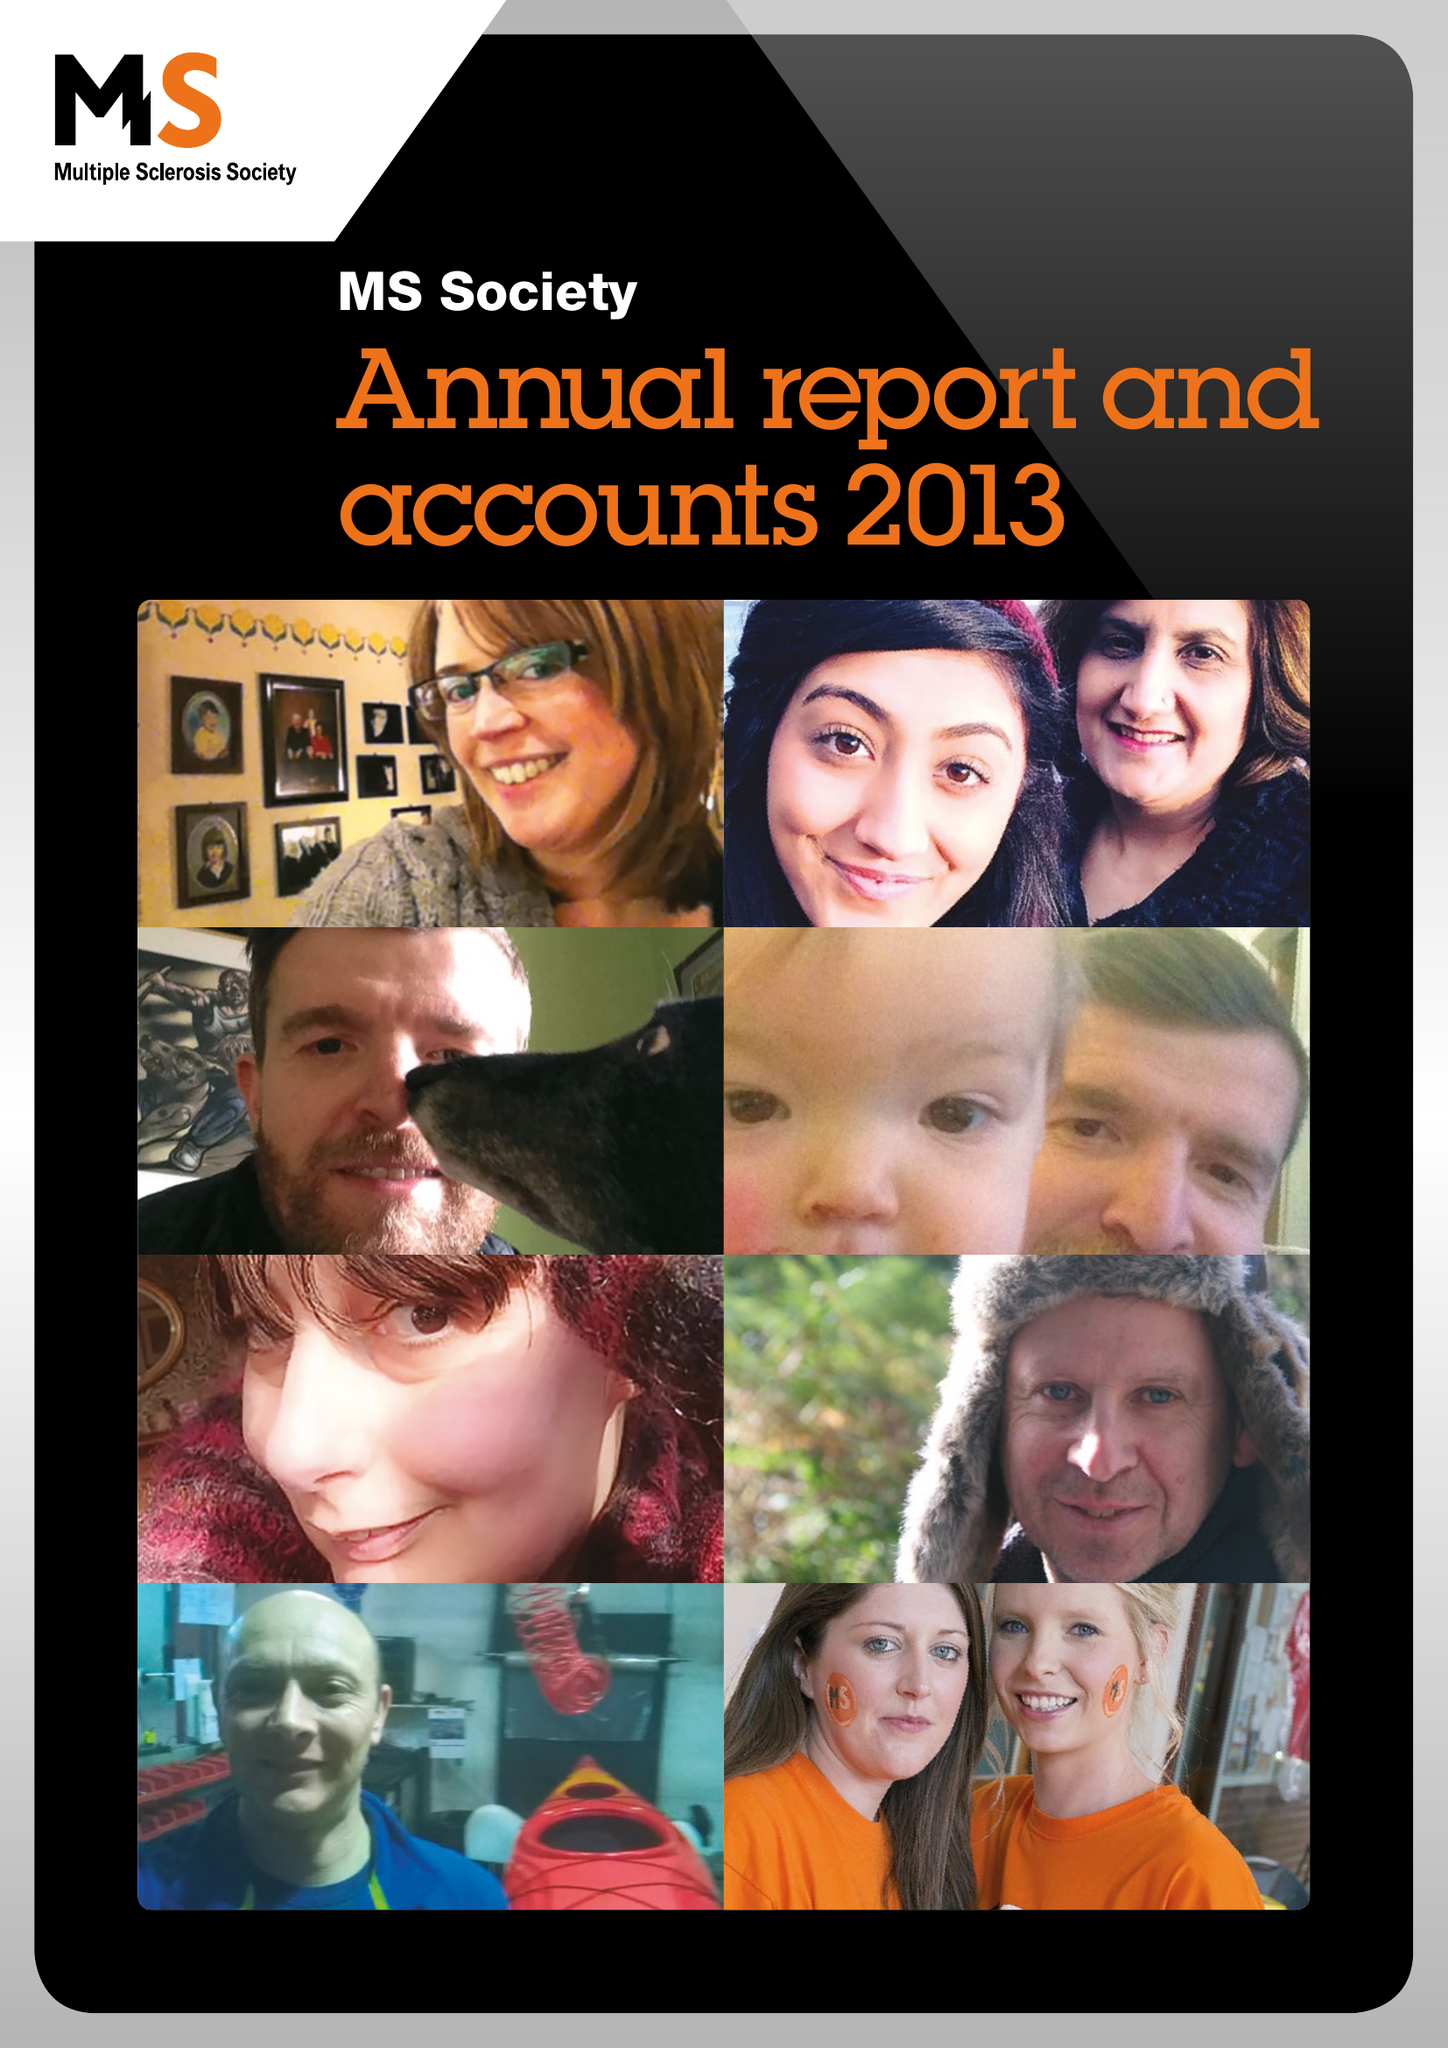What is the value for the charity_name?
Answer the question using a single word or phrase. Multiple Sclerosis Society 